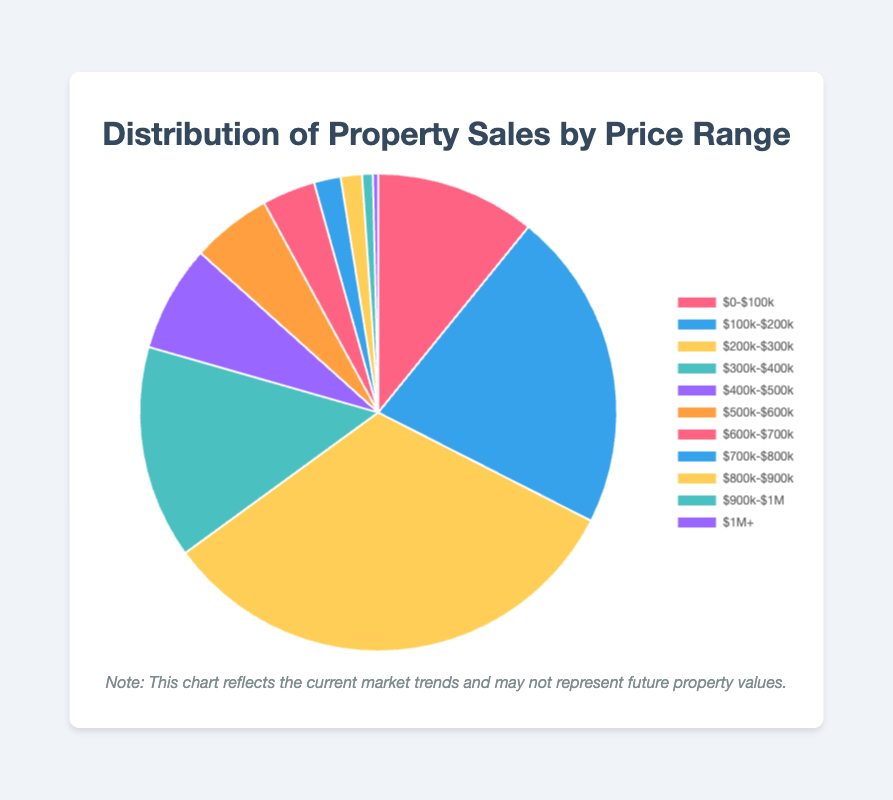What percentage of property sales are from the $200k-$300k price range? From the pie chart, locate the $200k-$300k price range segment. The tooltip shows the number of sales and percentage. It states 450 property sales, which is 30% of the total sales.
Answer: 30% How do the sales in the $0-$100k range compare to those in the $900k-$1M range? Compare the sales figures: $0-$100k has 150 sales, while $900k-$1M has 10 sales, making $0-$100k significantly higher.
Answer: $0-$100k has 140 more sales Which price range has the highest number of sales? Observe the pie chart, identify the largest slice which represents the $200k-$300k range with 450 sales.
Answer: $200k-$300k What is the combined percentage of property sales for the $500k-$600k and $600k-$700k ranges? $500k-$600k has 75 sales, and $600k-$700k has 50 sales. Sum the sales (75 + 50 = 125). Total sales are 1400. The combined percentage is (125/1400) * 100 ≈ 9%.
Answer: 9% Is the number of sales in the $400k-$500k range greater than the $100k-$200k range? Compare the figures: $400k-$500k has 100 sales, while $100k-$200k has 300 sales. $100k-$200k has more sales.
Answer: No What is the total number of property sales for all price ranges? Add up all the sales figures: 150 + 300 + 450 + 200 + 100 + 75 + 50 + 25 + 20 + 10 + 5 = 1400.
Answer: 1400 Which price range accounts for the smallest percentage of sales? Identify the smallest slice in the pie chart, which belongs to the $1M+ range with 5 sales.
Answer: $1M+ What is the difference in the number of sales between the $300k-$400k range and the $600k-$700k range? $300k-$400k has 200 sales, $600k-$700k has 50 sales. The difference is 200 - 50 = 150.
Answer: 150 How many sales are there in the price ranges above $500k? Sum the sales for $500k-$600k, $600k-$700k, $700k-$800k, $800k-$900k, $900k-$1M, and $1M+ (75 + 50 + 25 + 20 + 10 + 5 = 185).
Answer: 185 